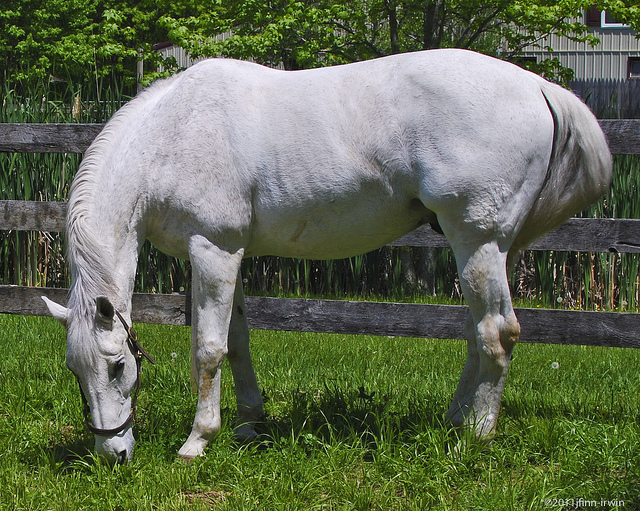Is the horse positioned closer to the left or the right side of the image? The horse is positioned centrally in the image but is slightly closer to the left side. 